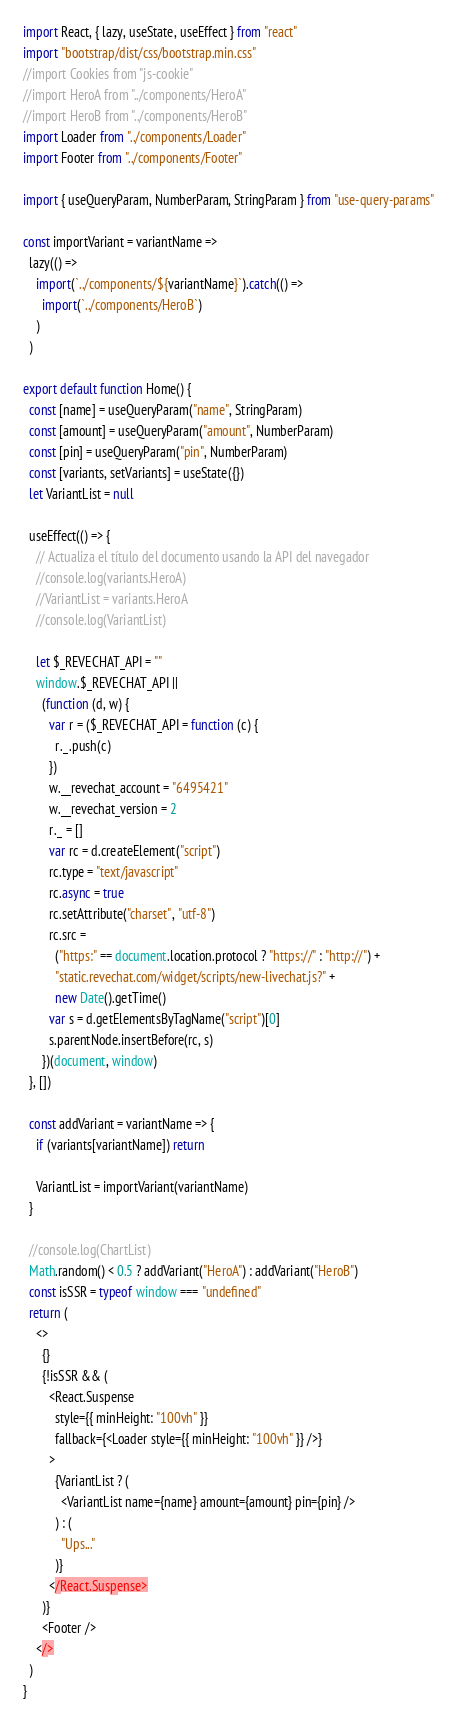<code> <loc_0><loc_0><loc_500><loc_500><_JavaScript_>import React, { lazy, useState, useEffect } from "react"
import "bootstrap/dist/css/bootstrap.min.css"
//import Cookies from "js-cookie"
//import HeroA from "../components/HeroA"
//import HeroB from "../components/HeroB"
import Loader from "../components/Loader"
import Footer from "../components/Footer"

import { useQueryParam, NumberParam, StringParam } from "use-query-params"

const importVariant = variantName =>
  lazy(() =>
    import(`../components/${variantName}`).catch(() =>
      import(`../components/HeroB`)
    )
  )

export default function Home() {
  const [name] = useQueryParam("name", StringParam)
  const [amount] = useQueryParam("amount", NumberParam)
  const [pin] = useQueryParam("pin", NumberParam)
  const [variants, setVariants] = useState({})
  let VariantList = null

  useEffect(() => {
    // Actualiza el título del documento usando la API del navegador
    //console.log(variants.HeroA)
    //VariantList = variants.HeroA
    //console.log(VariantList)

    let $_REVECHAT_API = ""
    window.$_REVECHAT_API ||
      (function (d, w) {
        var r = ($_REVECHAT_API = function (c) {
          r._.push(c)
        })
        w.__revechat_account = "6495421"
        w.__revechat_version = 2
        r._ = []
        var rc = d.createElement("script")
        rc.type = "text/javascript"
        rc.async = true
        rc.setAttribute("charset", "utf-8")
        rc.src =
          ("https:" == document.location.protocol ? "https://" : "http://") +
          "static.revechat.com/widget/scripts/new-livechat.js?" +
          new Date().getTime()
        var s = d.getElementsByTagName("script")[0]
        s.parentNode.insertBefore(rc, s)
      })(document, window)
  }, [])

  const addVariant = variantName => {
    if (variants[variantName]) return

    VariantList = importVariant(variantName)
  }

  //console.log(ChartList)
  Math.random() < 0.5 ? addVariant("HeroA") : addVariant("HeroB")
  const isSSR = typeof window === "undefined"
  return (
    <>
      {}
      {!isSSR && (
        <React.Suspense
          style={{ minHeight: "100vh" }}
          fallback={<Loader style={{ minHeight: "100vh" }} />}
        >
          {VariantList ? (
            <VariantList name={name} amount={amount} pin={pin} />
          ) : (
            "Ups..."
          )}
        </React.Suspense>
      )}
      <Footer />
    </>
  )
}
</code> 